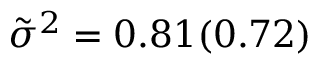<formula> <loc_0><loc_0><loc_500><loc_500>\tilde { \sigma } ^ { 2 } = 0 . 8 1 ( 0 . 7 2 )</formula> 